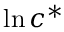Convert formula to latex. <formula><loc_0><loc_0><loc_500><loc_500>\ln { { c } ^ { * } }</formula> 